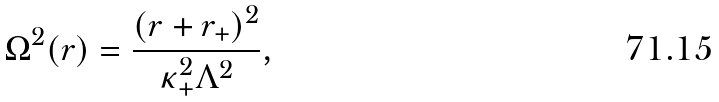<formula> <loc_0><loc_0><loc_500><loc_500>\Omega ^ { 2 } ( r ) = \frac { ( r + r _ { + } ) ^ { 2 } } { \kappa _ { + } ^ { 2 } \Lambda ^ { 2 } } ,</formula> 